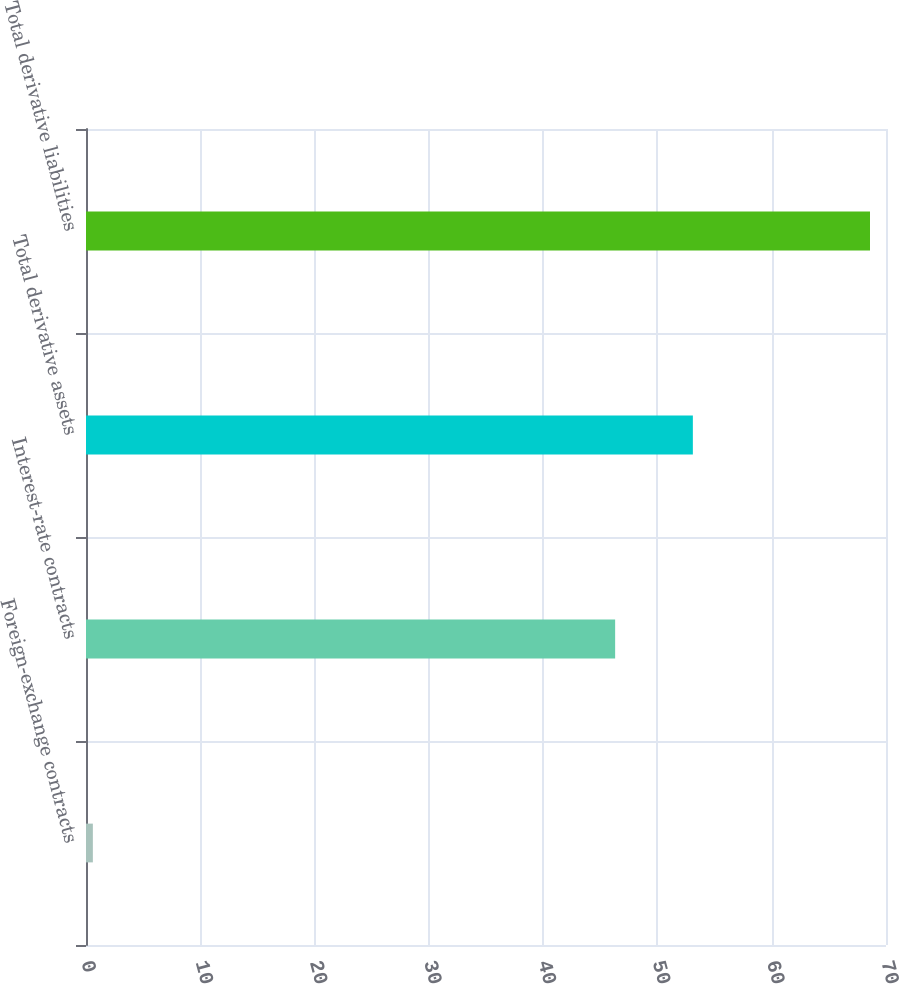Convert chart to OTSL. <chart><loc_0><loc_0><loc_500><loc_500><bar_chart><fcel>Foreign-exchange contracts<fcel>Interest-rate contracts<fcel>Total derivative assets<fcel>Total derivative liabilities<nl><fcel>0.6<fcel>46.3<fcel>53.1<fcel>68.6<nl></chart> 